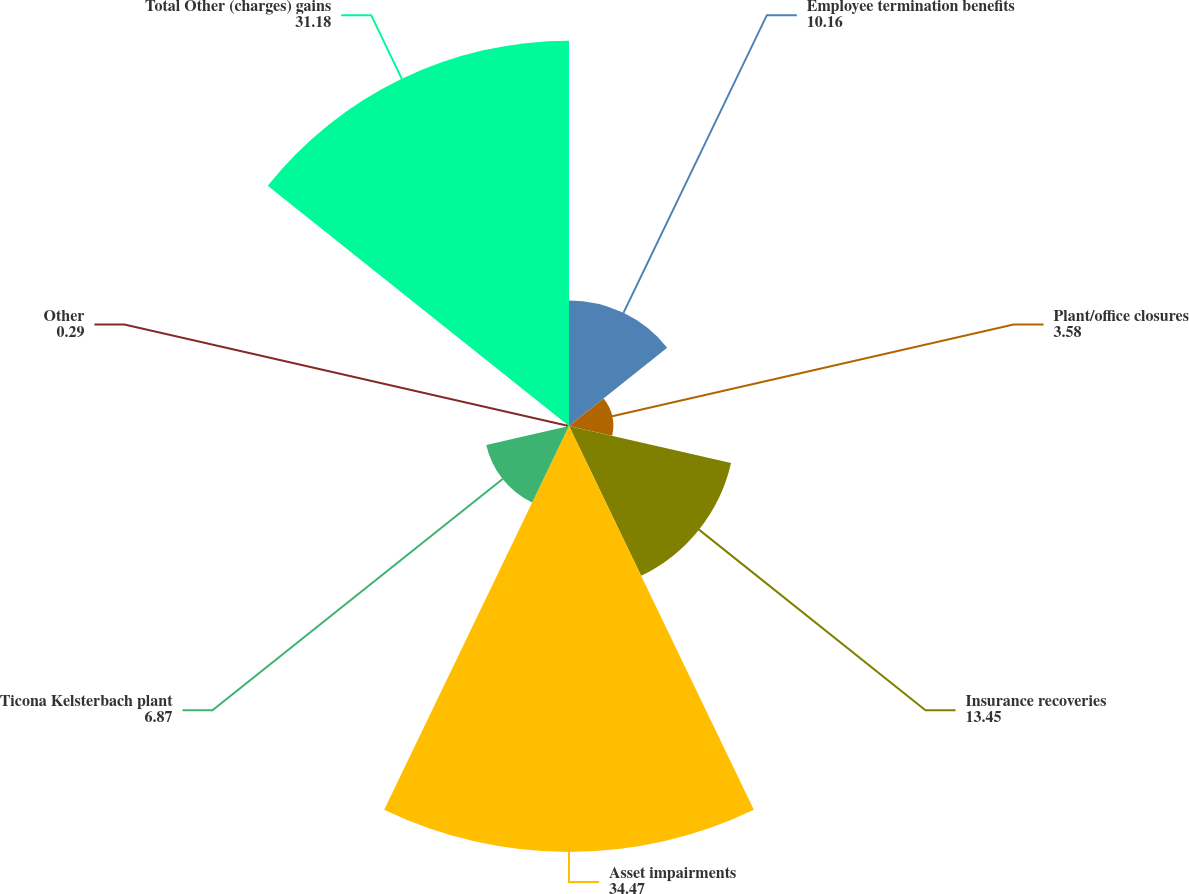Convert chart. <chart><loc_0><loc_0><loc_500><loc_500><pie_chart><fcel>Employee termination benefits<fcel>Plant/office closures<fcel>Insurance recoveries<fcel>Asset impairments<fcel>Ticona Kelsterbach plant<fcel>Other<fcel>Total Other (charges) gains<nl><fcel>10.16%<fcel>3.58%<fcel>13.45%<fcel>34.47%<fcel>6.87%<fcel>0.29%<fcel>31.18%<nl></chart> 